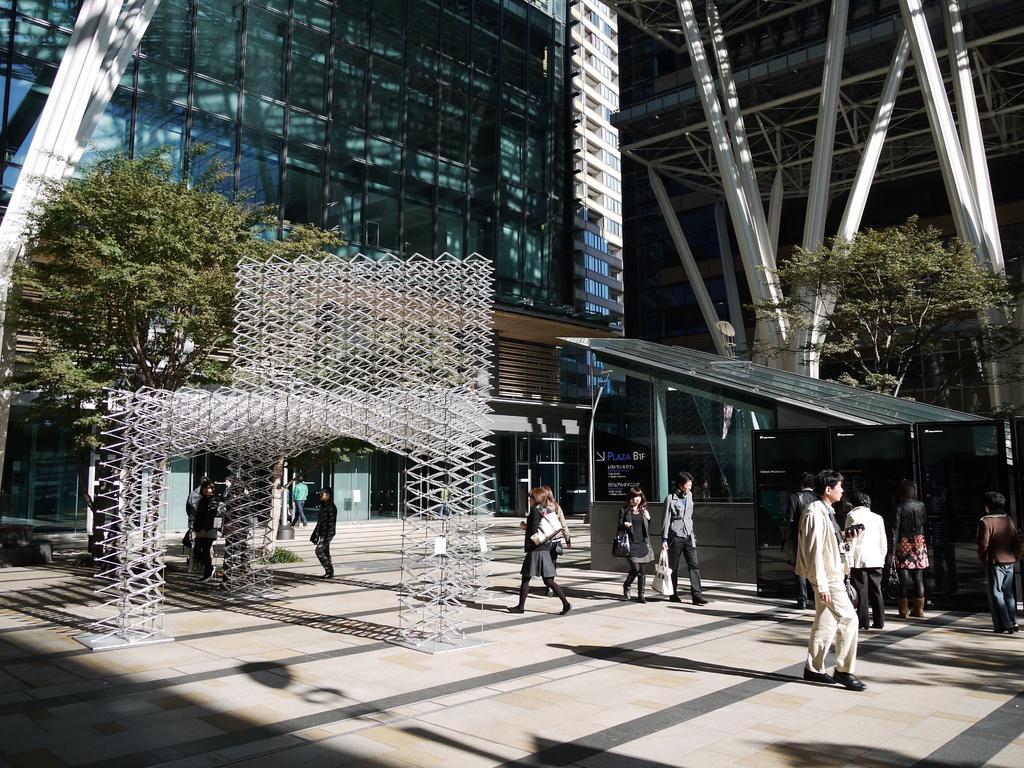Please provide a concise description of this image. In this picture we can see a building, beams, trees, board, few objects and the people. 